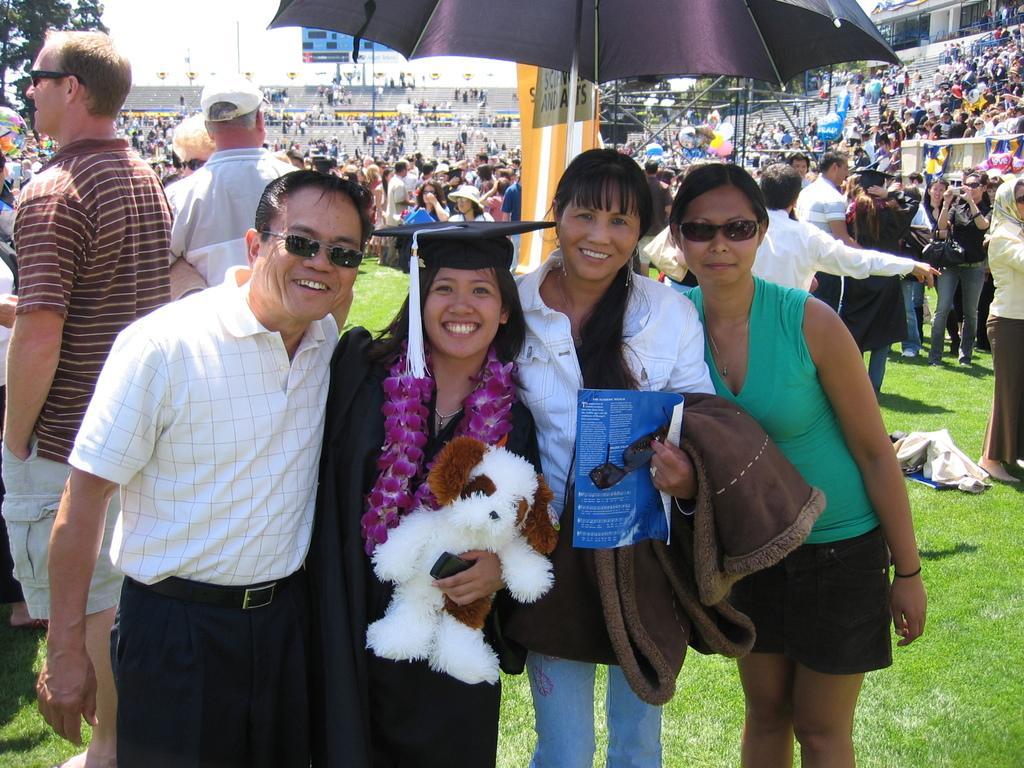In one or two sentences, can you explain what this image depicts? Here we can see a four people who are standing under umbrella. In the background we can see a group of people standing. 